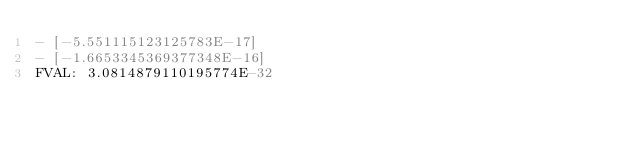<code> <loc_0><loc_0><loc_500><loc_500><_YAML_>- [-5.551115123125783E-17]
- [-1.6653345369377348E-16]
FVAL: 3.0814879110195774E-32
</code> 